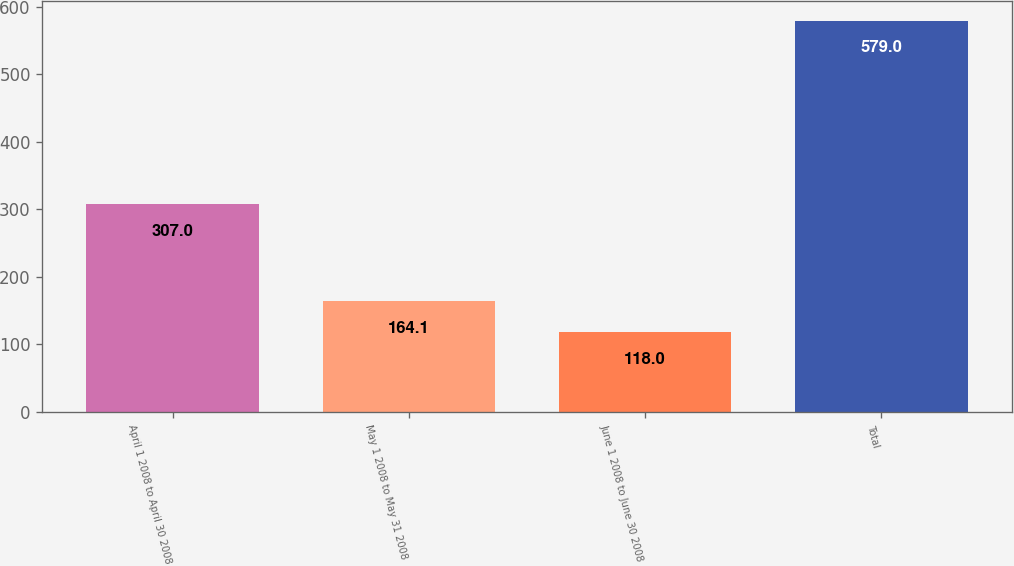Convert chart to OTSL. <chart><loc_0><loc_0><loc_500><loc_500><bar_chart><fcel>April 1 2008 to April 30 2008<fcel>May 1 2008 to May 31 2008<fcel>June 1 2008 to June 30 2008<fcel>Total<nl><fcel>307<fcel>164.1<fcel>118<fcel>579<nl></chart> 